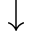<formula> <loc_0><loc_0><loc_500><loc_500>\downarrow</formula> 